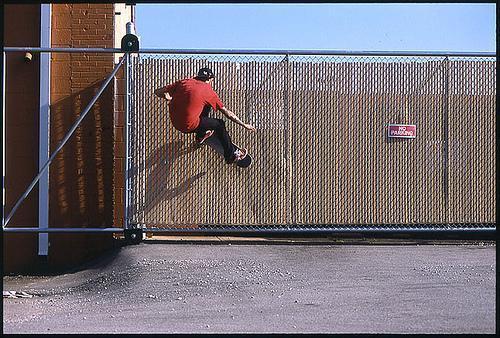How many skateboarders are shown?
Give a very brief answer. 1. 